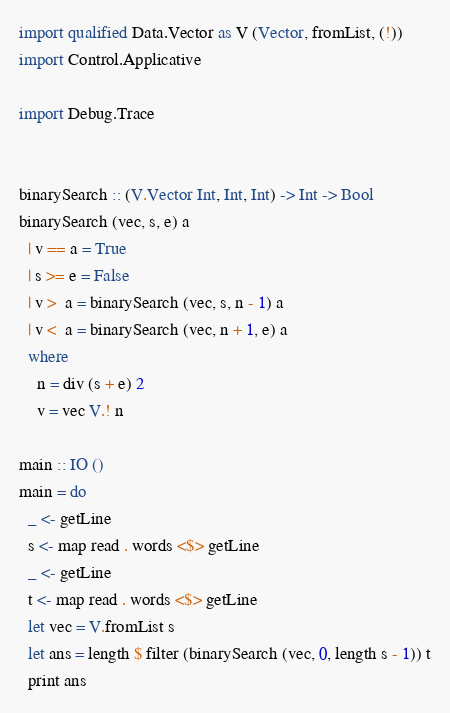<code> <loc_0><loc_0><loc_500><loc_500><_Haskell_>import qualified Data.Vector as V (Vector, fromList, (!))
import Control.Applicative

import Debug.Trace


binarySearch :: (V.Vector Int, Int, Int) -> Int -> Bool
binarySearch (vec, s, e) a
  | v == a = True
  | s >= e = False
  | v >  a = binarySearch (vec, s, n - 1) a
  | v <  a = binarySearch (vec, n + 1, e) a
  where
    n = div (s + e) 2
    v = vec V.! n

main :: IO ()
main = do
  _ <- getLine
  s <- map read . words <$> getLine
  _ <- getLine
  t <- map read . words <$> getLine
  let vec = V.fromList s
  let ans = length $ filter (binarySearch (vec, 0, length s - 1)) t
  print ans

</code> 